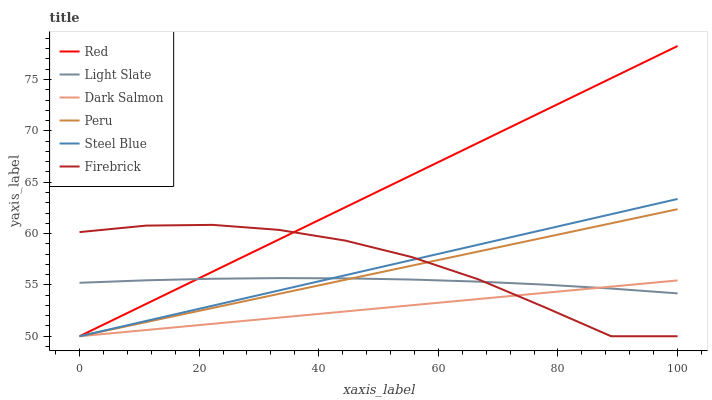Does Dark Salmon have the minimum area under the curve?
Answer yes or no. Yes. Does Red have the maximum area under the curve?
Answer yes or no. Yes. Does Firebrick have the minimum area under the curve?
Answer yes or no. No. Does Firebrick have the maximum area under the curve?
Answer yes or no. No. Is Steel Blue the smoothest?
Answer yes or no. Yes. Is Firebrick the roughest?
Answer yes or no. Yes. Is Dark Salmon the smoothest?
Answer yes or no. No. Is Dark Salmon the roughest?
Answer yes or no. No. Does Firebrick have the lowest value?
Answer yes or no. Yes. Does Red have the highest value?
Answer yes or no. Yes. Does Firebrick have the highest value?
Answer yes or no. No. Does Light Slate intersect Red?
Answer yes or no. Yes. Is Light Slate less than Red?
Answer yes or no. No. Is Light Slate greater than Red?
Answer yes or no. No. 